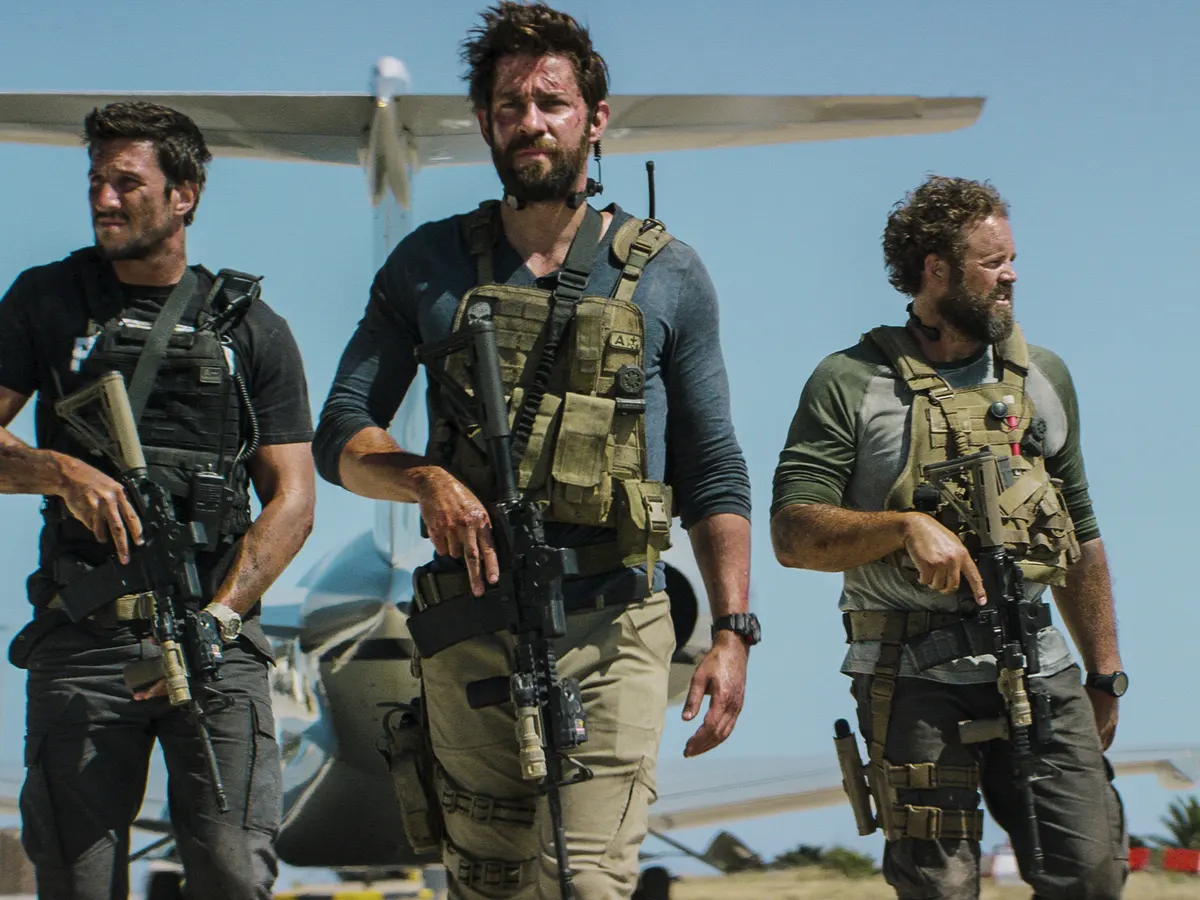What could be the possible operation these men are engaged in based on their attire and equipment? Based on their heavily equipped appearance with tactical vests and rifles, and the setting of an airstrip with an airplane ready, they might be preparing for an extraction or insertion mission related to military or paramilitary operations. Their serious expressions and tactical readiness suggest a high-stakes scenario possibly involving conflict or rescue operations. 